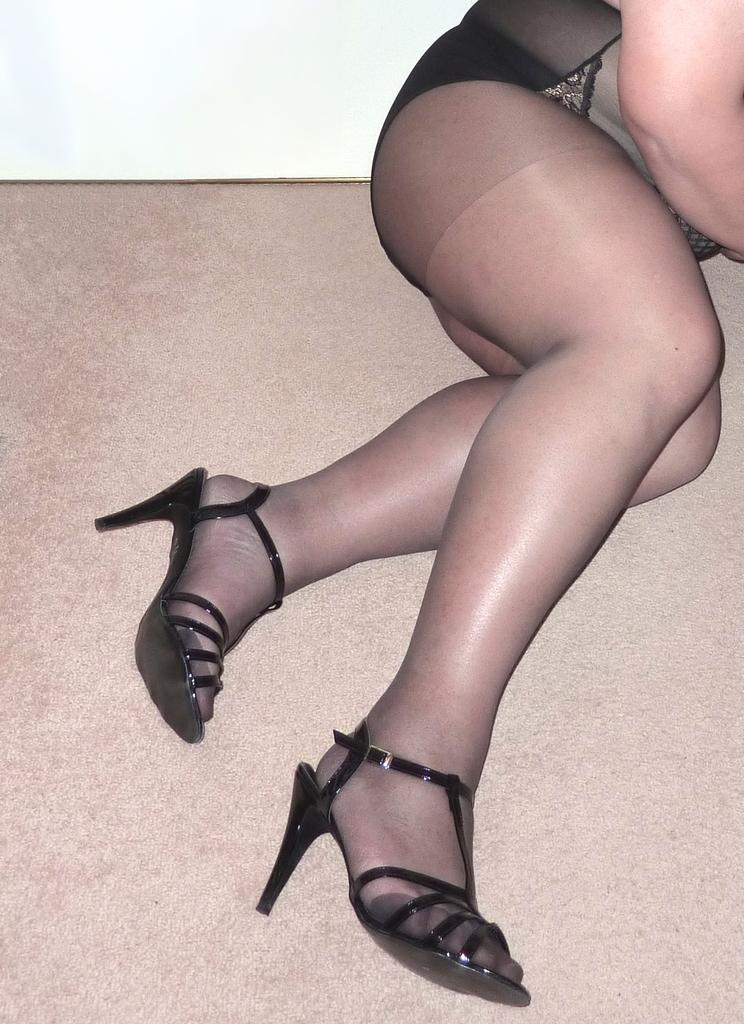Who or what is present in the image? There is a person in the image. What is the person wearing? The person is wearing a black dress and black heels. What type of pie is being served on a plate in the image? There is no pie present in the image; it features a person wearing a black dress and black heels. What color is the flame coming from the candle in the image? There is no candle or flame present in the image. 